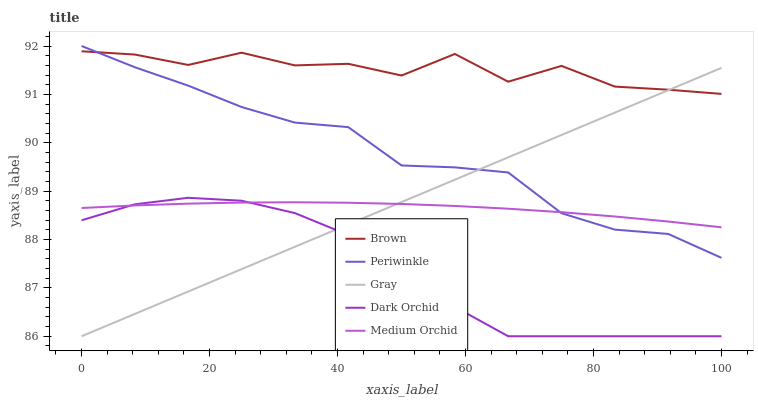Does Dark Orchid have the minimum area under the curve?
Answer yes or no. Yes. Does Brown have the maximum area under the curve?
Answer yes or no. Yes. Does Medium Orchid have the minimum area under the curve?
Answer yes or no. No. Does Medium Orchid have the maximum area under the curve?
Answer yes or no. No. Is Gray the smoothest?
Answer yes or no. Yes. Is Brown the roughest?
Answer yes or no. Yes. Is Medium Orchid the smoothest?
Answer yes or no. No. Is Medium Orchid the roughest?
Answer yes or no. No. Does Dark Orchid have the lowest value?
Answer yes or no. Yes. Does Medium Orchid have the lowest value?
Answer yes or no. No. Does Periwinkle have the highest value?
Answer yes or no. Yes. Does Medium Orchid have the highest value?
Answer yes or no. No. Is Dark Orchid less than Periwinkle?
Answer yes or no. Yes. Is Brown greater than Dark Orchid?
Answer yes or no. Yes. Does Brown intersect Gray?
Answer yes or no. Yes. Is Brown less than Gray?
Answer yes or no. No. Is Brown greater than Gray?
Answer yes or no. No. Does Dark Orchid intersect Periwinkle?
Answer yes or no. No. 